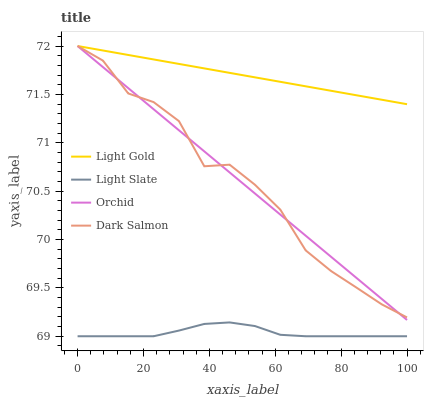Does Light Slate have the minimum area under the curve?
Answer yes or no. Yes. Does Light Gold have the maximum area under the curve?
Answer yes or no. Yes. Does Dark Salmon have the minimum area under the curve?
Answer yes or no. No. Does Dark Salmon have the maximum area under the curve?
Answer yes or no. No. Is Light Gold the smoothest?
Answer yes or no. Yes. Is Dark Salmon the roughest?
Answer yes or no. Yes. Is Dark Salmon the smoothest?
Answer yes or no. No. Is Light Gold the roughest?
Answer yes or no. No. Does Light Slate have the lowest value?
Answer yes or no. Yes. Does Dark Salmon have the lowest value?
Answer yes or no. No. Does Orchid have the highest value?
Answer yes or no. Yes. Is Light Slate less than Light Gold?
Answer yes or no. Yes. Is Light Gold greater than Light Slate?
Answer yes or no. Yes. Does Orchid intersect Dark Salmon?
Answer yes or no. Yes. Is Orchid less than Dark Salmon?
Answer yes or no. No. Is Orchid greater than Dark Salmon?
Answer yes or no. No. Does Light Slate intersect Light Gold?
Answer yes or no. No. 